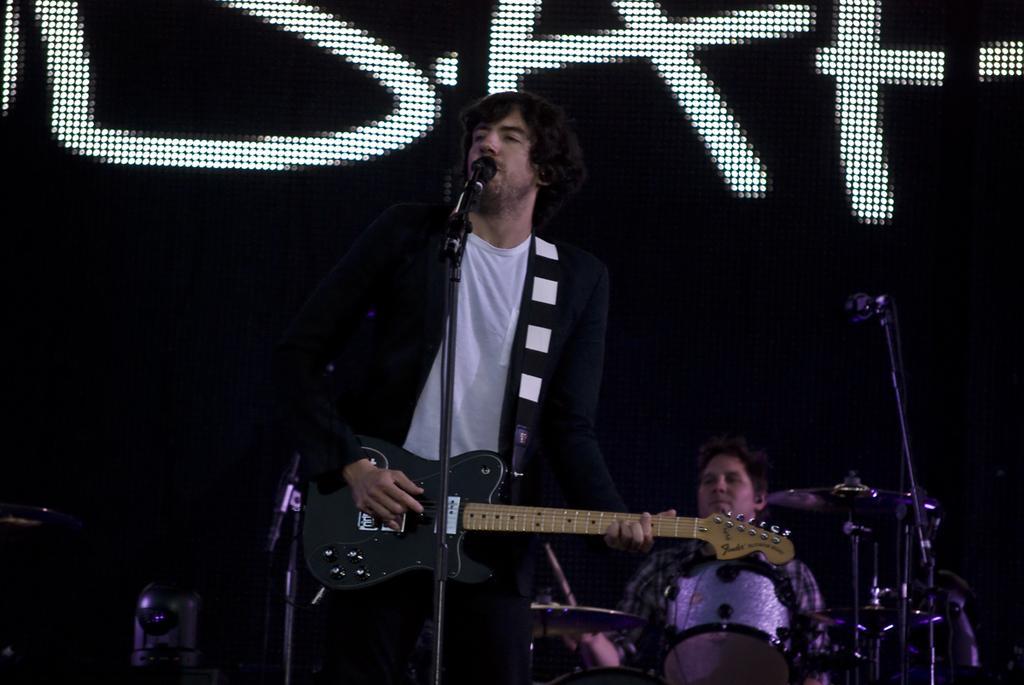How would you summarize this image in a sentence or two? This is the man standing and playing guitar. He is singing a song. These are the mics attached to the mike stands. I can see a person sitting and playing the drums. This looks like a screen with a display. I think this is a stage show. 